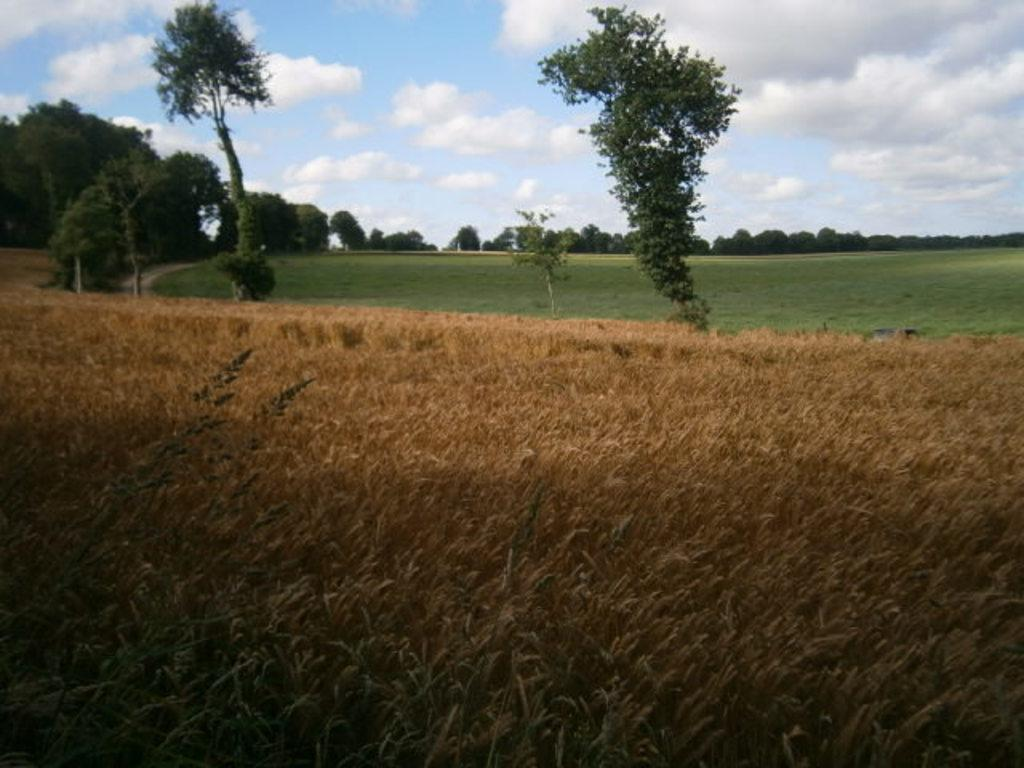What type of vegetation can be seen at the bottom of the image? There are crops at the bottom of the image. What other types of vegetation are visible in the image? There are trees and grass in the background of the image. What is visible at the top of the image? The sky is visible at the top of the image. Who is the manager of the crops in the image? There is no information about a manager in the image, as it only shows crops, trees, grass, and the sky. 